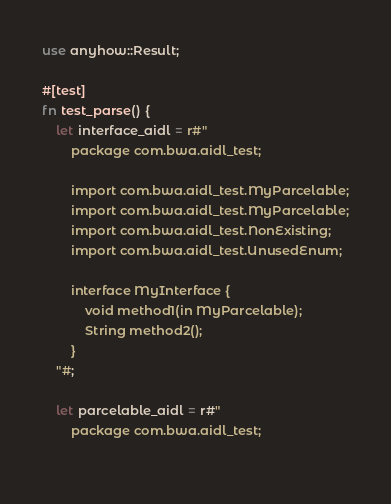<code> <loc_0><loc_0><loc_500><loc_500><_Rust_>use anyhow::Result;

#[test]
fn test_parse() {
    let interface_aidl = r#"
        package com.bwa.aidl_test;
    
        import com.bwa.aidl_test.MyParcelable;
        import com.bwa.aidl_test.MyParcelable;
        import com.bwa.aidl_test.NonExisting;
        import com.bwa.aidl_test.UnusedEnum;

        interface MyInterface {
            void method1(in MyParcelable);
            String method2();
        }
    "#;

    let parcelable_aidl = r#"
        package com.bwa.aidl_test;
    </code> 